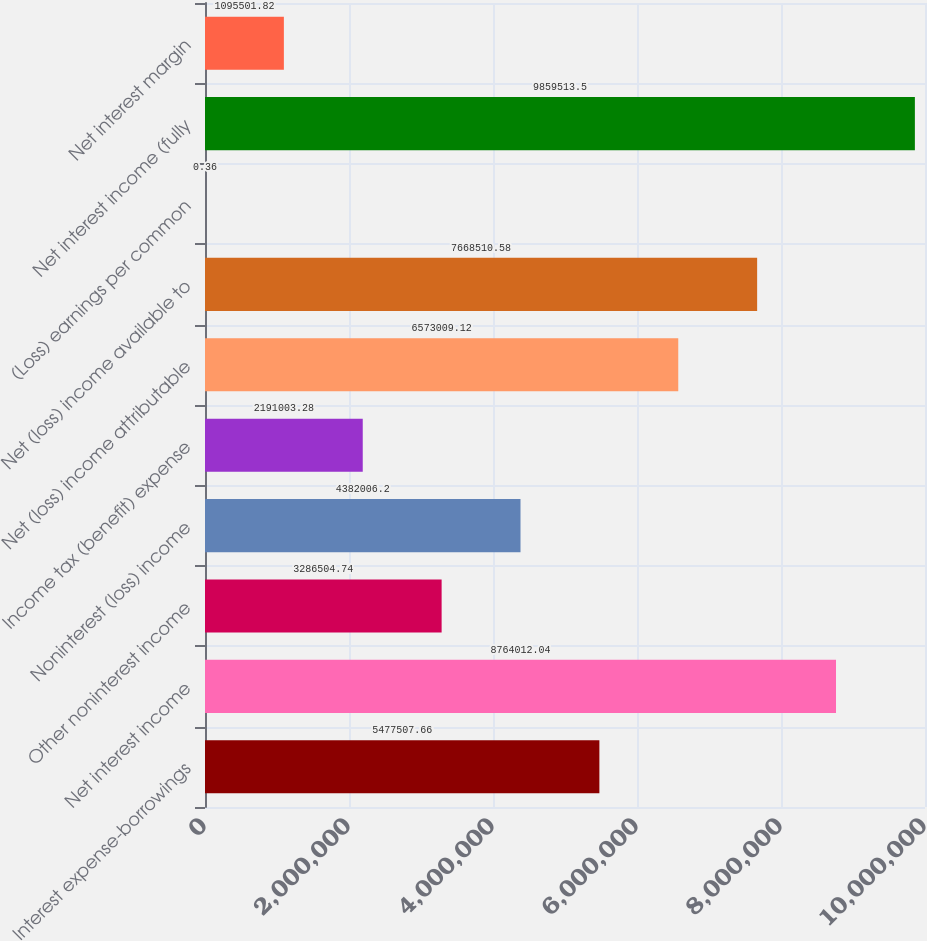<chart> <loc_0><loc_0><loc_500><loc_500><bar_chart><fcel>Interest expense-borrowings<fcel>Net interest income<fcel>Other noninterest income<fcel>Noninterest (loss) income<fcel>Income tax (benefit) expense<fcel>Net (loss) income attributable<fcel>Net (loss) income available to<fcel>(Loss) earnings per common<fcel>Net interest income (fully<fcel>Net interest margin<nl><fcel>5.47751e+06<fcel>8.76401e+06<fcel>3.2865e+06<fcel>4.38201e+06<fcel>2.191e+06<fcel>6.57301e+06<fcel>7.66851e+06<fcel>0.36<fcel>9.85951e+06<fcel>1.0955e+06<nl></chart> 